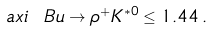<formula> <loc_0><loc_0><loc_500><loc_500>\ a x i { \ B u \to \rho ^ { + } K ^ { * 0 } } \leq 1 . 4 4 \, .</formula> 